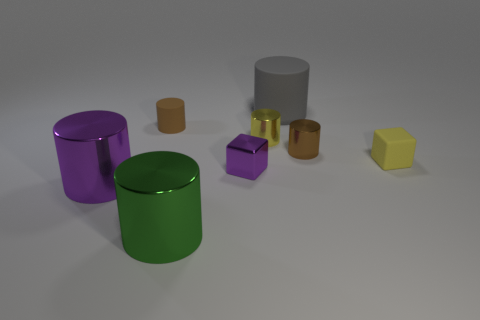Subtract all big purple cylinders. How many cylinders are left? 5 Subtract 1 cubes. How many cubes are left? 1 Add 2 tiny green rubber things. How many objects exist? 10 Subtract all brown cylinders. How many cylinders are left? 4 Subtract all cyan cylinders. Subtract all brown balls. How many cylinders are left? 6 Subtract all blue balls. How many brown cylinders are left? 2 Subtract all yellow cylinders. Subtract all small brown metal things. How many objects are left? 6 Add 3 gray rubber objects. How many gray rubber objects are left? 4 Add 8 big brown cylinders. How many big brown cylinders exist? 8 Subtract 0 purple spheres. How many objects are left? 8 